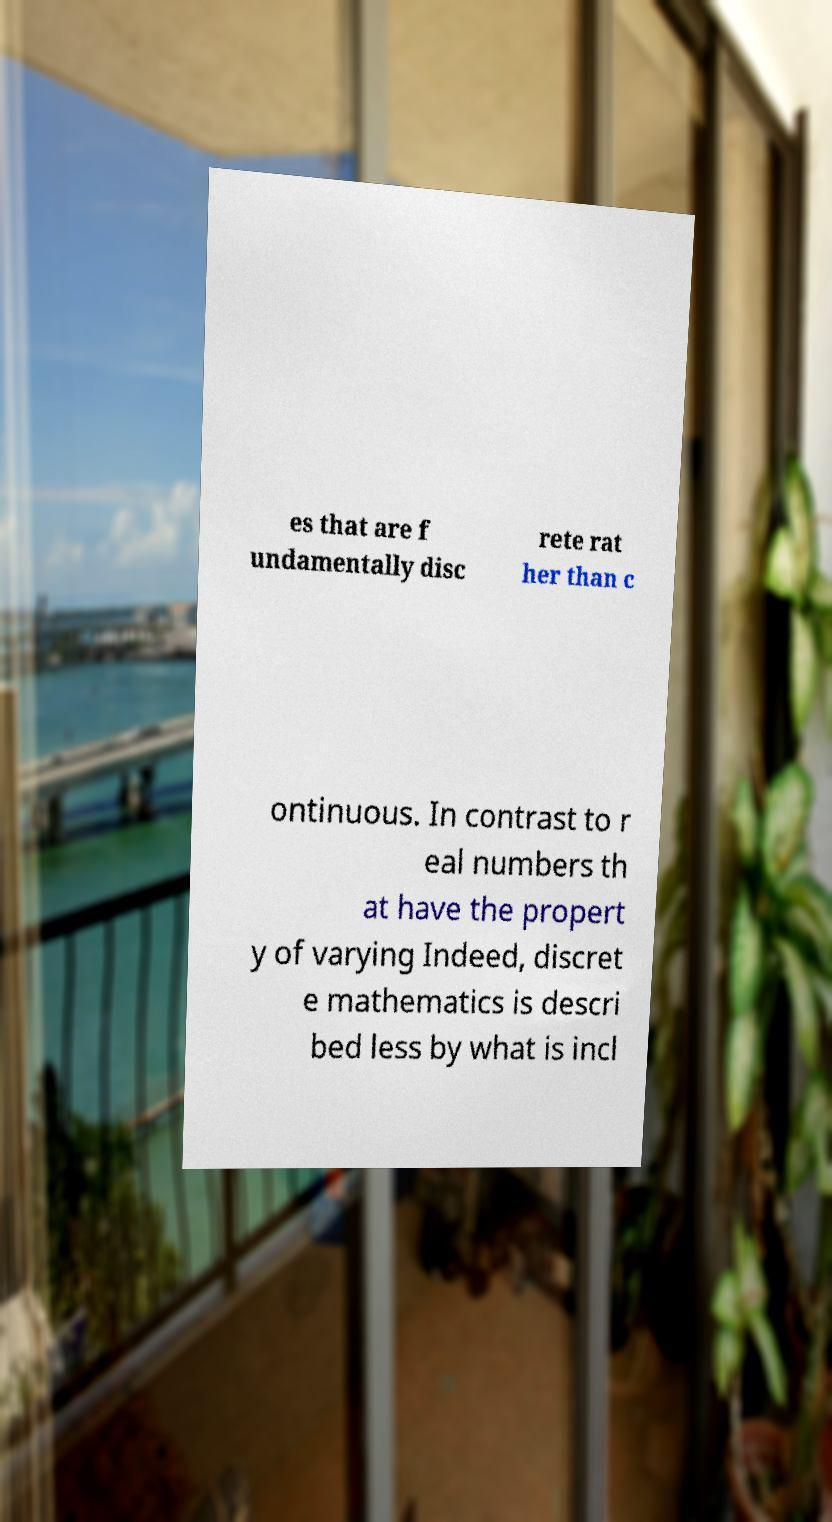For documentation purposes, I need the text within this image transcribed. Could you provide that? es that are f undamentally disc rete rat her than c ontinuous. In contrast to r eal numbers th at have the propert y of varying Indeed, discret e mathematics is descri bed less by what is incl 